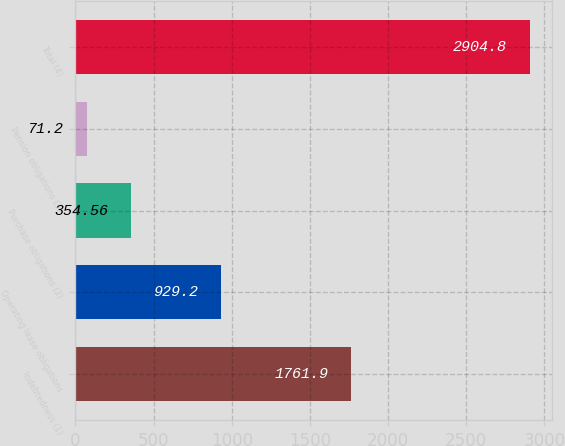Convert chart. <chart><loc_0><loc_0><loc_500><loc_500><bar_chart><fcel>Indebtedness (1)<fcel>Operating lease obligations<fcel>Purchase obligations (2)<fcel>Pension obligations (3)<fcel>Total (4)<nl><fcel>1761.9<fcel>929.2<fcel>354.56<fcel>71.2<fcel>2904.8<nl></chart> 